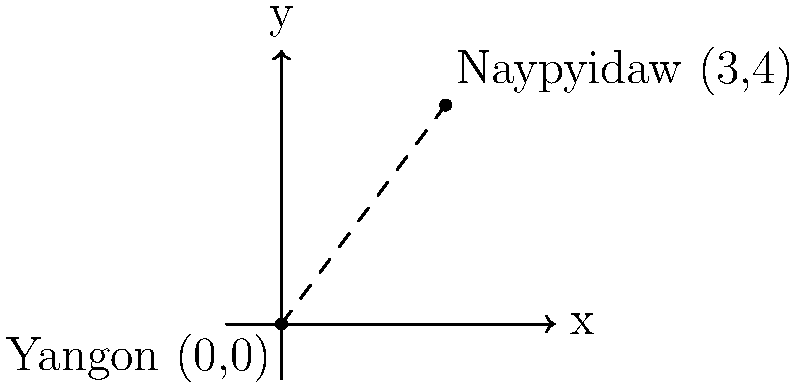In a simplified coordinate system representing Myanmar's geography, Yangon is located at (0,0) and Naypyidaw, the capital city, is at (3,4). Calculate the straight-line distance between these two cities. Round your answer to the nearest kilometer, assuming each unit on the coordinate plane represents 100 km. To solve this problem, we'll use the distance formula derived from the Pythagorean theorem:

1) The distance formula is: $d = \sqrt{(x_2-x_1)^2 + (y_2-y_1)^2}$

2) We have:
   Yangon: $(x_1, y_1) = (0, 0)$
   Naypyidaw: $(x_2, y_2) = (3, 4)$

3) Plugging these into the formula:
   $d = \sqrt{(3-0)^2 + (4-0)^2}$

4) Simplify:
   $d = \sqrt{3^2 + 4^2}$
   $d = \sqrt{9 + 16}$
   $d = \sqrt{25}$
   $d = 5$

5) Since each unit represents 100 km:
   Actual distance $= 5 \times 100 = 500$ km

Therefore, the straight-line distance between Yangon and Naypyidaw is 500 km.
Answer: 500 km 